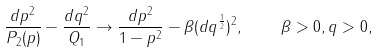Convert formula to latex. <formula><loc_0><loc_0><loc_500><loc_500>\frac { d p ^ { 2 } } { P _ { 2 } ( p ) } - \frac { d q ^ { 2 } } { Q _ { 1 } } \to \frac { d p ^ { 2 } } { 1 - p ^ { 2 } } - \beta ( d q ^ { \frac { 1 } { 2 } } ) ^ { 2 } , \quad \beta > 0 , q > 0 ,</formula> 